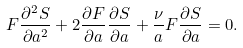Convert formula to latex. <formula><loc_0><loc_0><loc_500><loc_500>F \frac { \partial ^ { 2 } S } { \partial a ^ { 2 } } + 2 \frac { \partial F } { \partial a } \frac { \partial S } { \partial a } + \frac { \nu } { a } F \frac { \partial S } { \partial a } = 0 .</formula> 